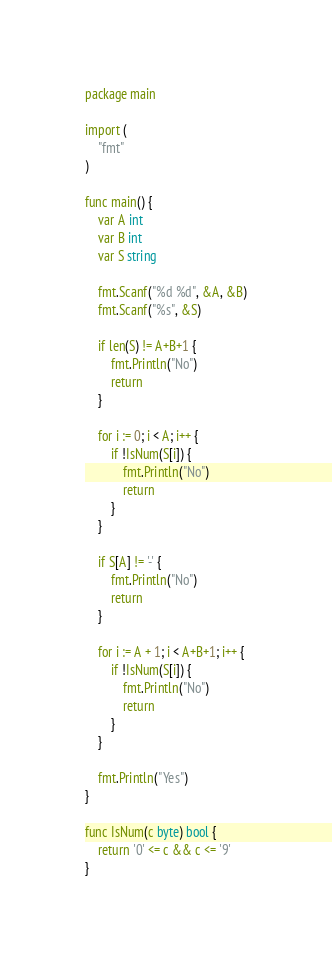Convert code to text. <code><loc_0><loc_0><loc_500><loc_500><_Go_>package main

import (
	"fmt"
)

func main() {
	var A int
	var B int
	var S string

	fmt.Scanf("%d %d", &A, &B)
	fmt.Scanf("%s", &S)

	if len(S) != A+B+1 {
		fmt.Println("No")
		return
	}

	for i := 0; i < A; i++ {
		if !IsNum(S[i]) {
			fmt.Println("No")
			return
		}
	}

	if S[A] != '-' {
		fmt.Println("No")
		return
	}

	for i := A + 1; i < A+B+1; i++ {
		if !IsNum(S[i]) {
			fmt.Println("No")
			return
		}
	}

	fmt.Println("Yes")
}

func IsNum(c byte) bool {
	return '0' <= c && c <= '9'
}
</code> 